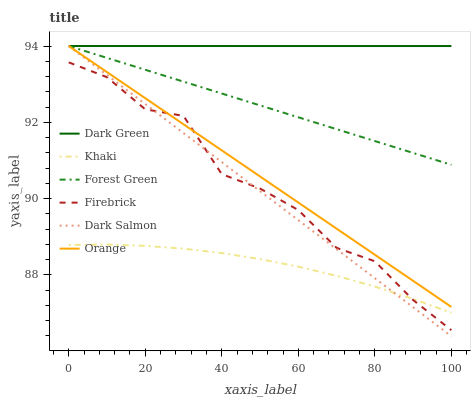Does Firebrick have the minimum area under the curve?
Answer yes or no. No. Does Firebrick have the maximum area under the curve?
Answer yes or no. No. Is Dark Salmon the smoothest?
Answer yes or no. No. Is Dark Salmon the roughest?
Answer yes or no. No. Does Firebrick have the lowest value?
Answer yes or no. No. Does Firebrick have the highest value?
Answer yes or no. No. Is Khaki less than Orange?
Answer yes or no. Yes. Is Forest Green greater than Firebrick?
Answer yes or no. Yes. Does Khaki intersect Orange?
Answer yes or no. No. 